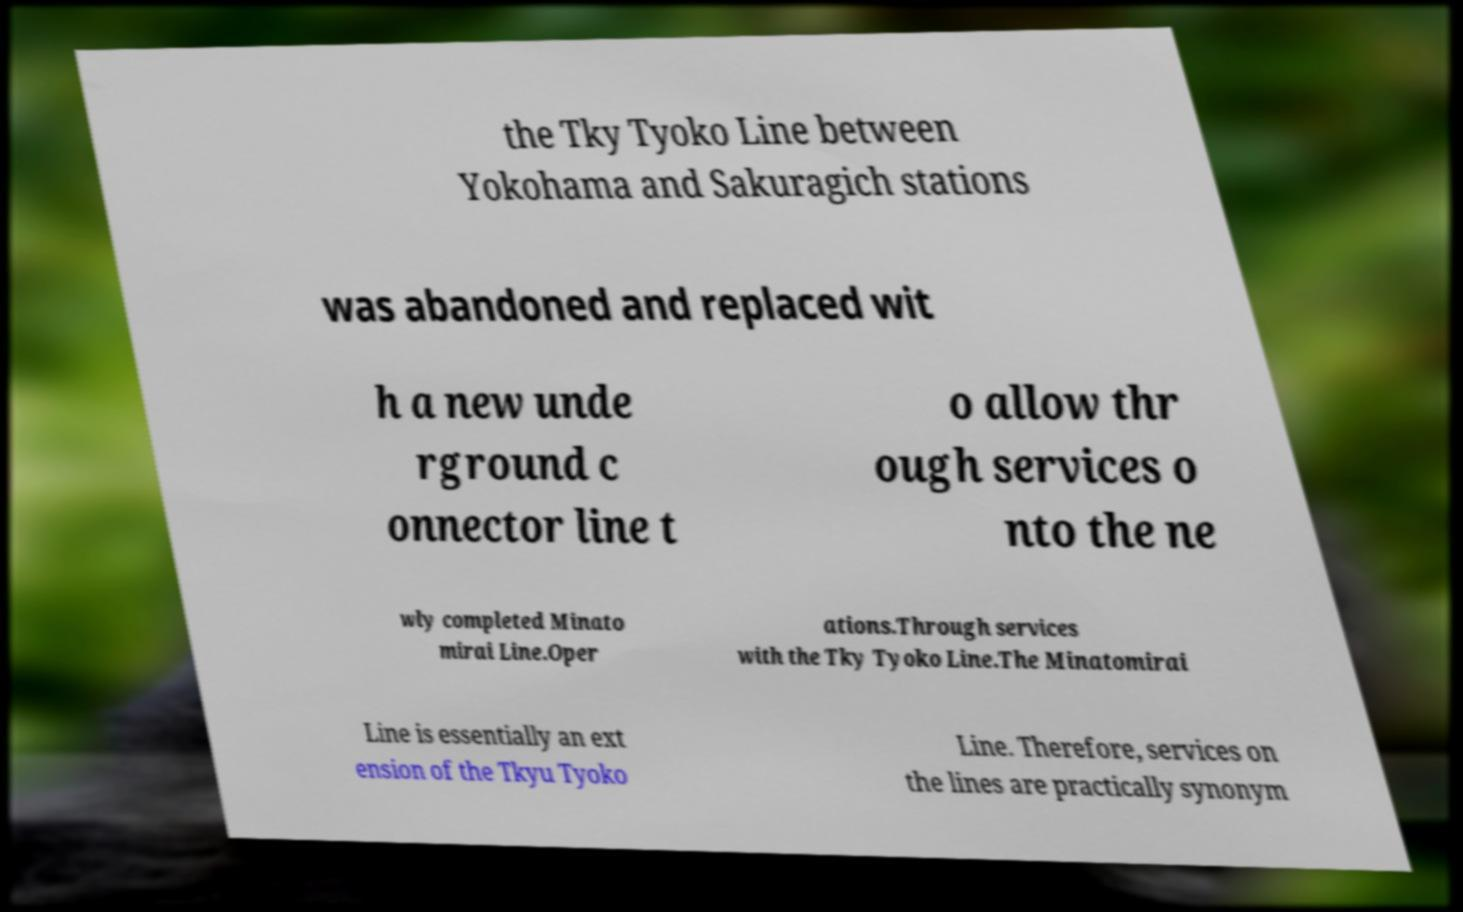What messages or text are displayed in this image? I need them in a readable, typed format. the Tky Tyoko Line between Yokohama and Sakuragich stations was abandoned and replaced wit h a new unde rground c onnector line t o allow thr ough services o nto the ne wly completed Minato mirai Line.Oper ations.Through services with the Tky Tyoko Line.The Minatomirai Line is essentially an ext ension of the Tkyu Tyoko Line. Therefore, services on the lines are practically synonym 